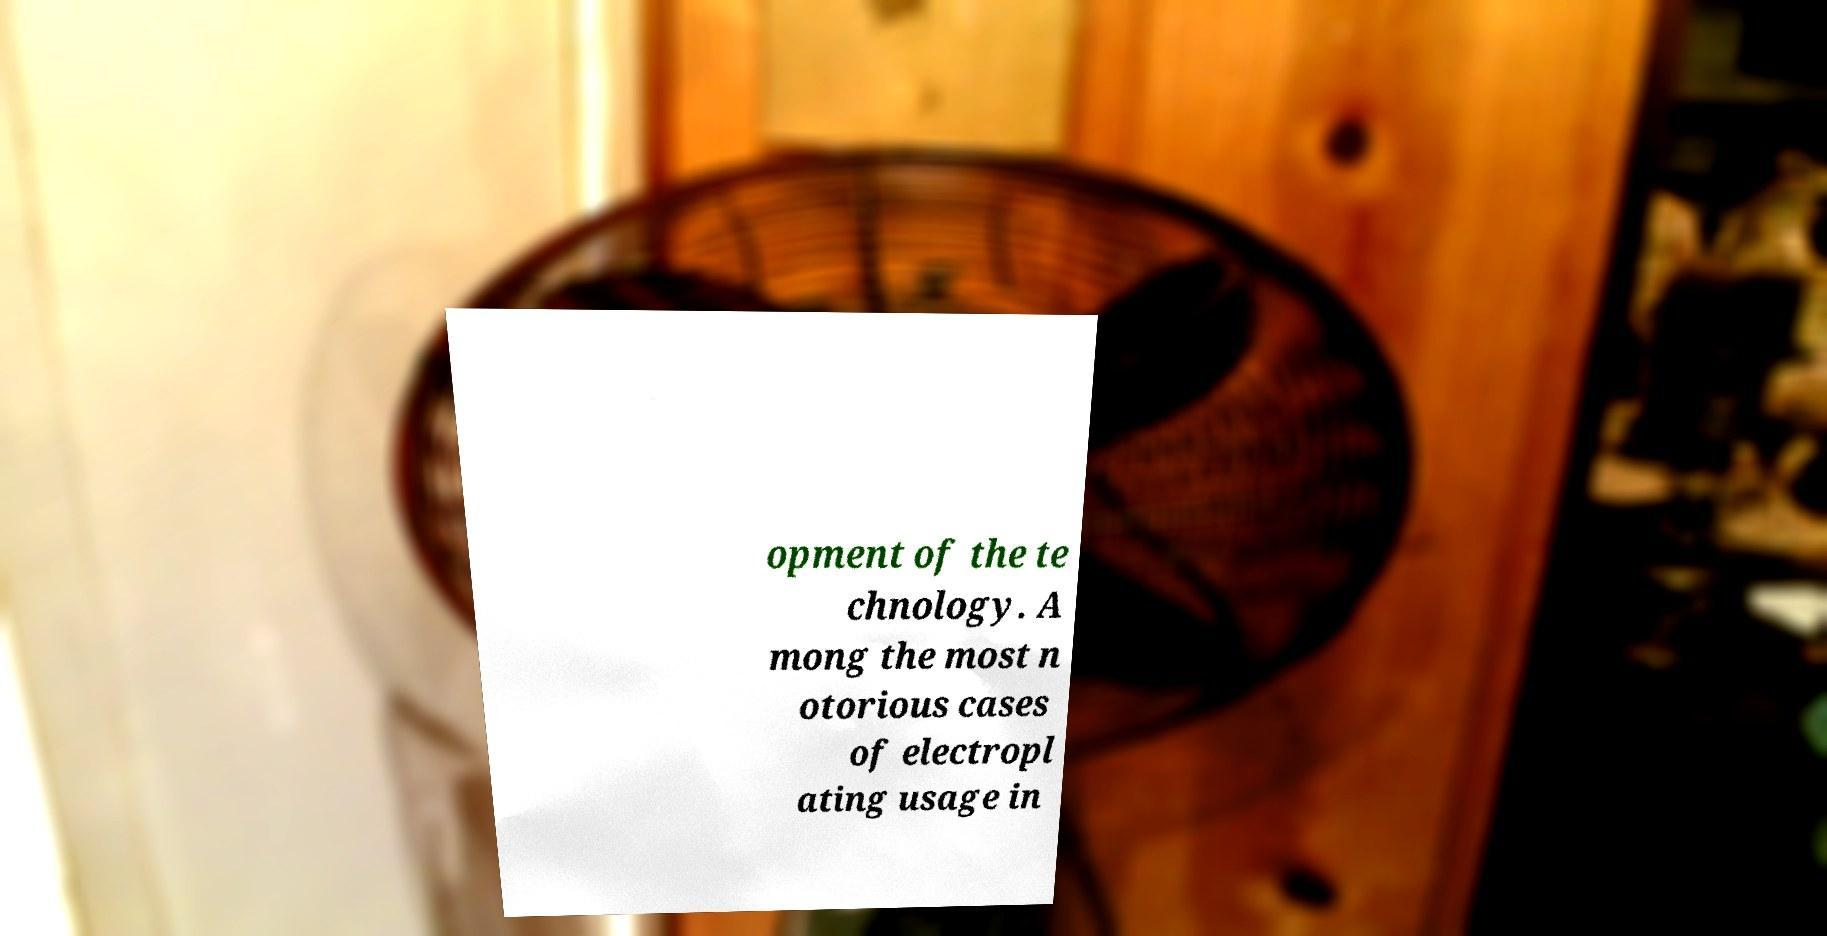Can you accurately transcribe the text from the provided image for me? opment of the te chnology. A mong the most n otorious cases of electropl ating usage in 